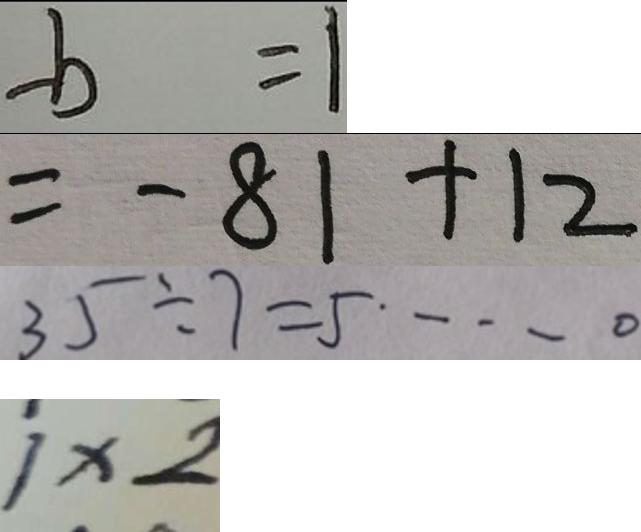<formula> <loc_0><loc_0><loc_500><loc_500>- b = 1 
 = - 8 1 + 1 2 
 3 5 \div 7 = 5 \cdots 0 
 1 \times 2</formula> 